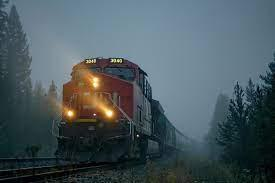What is the weather like in the image, and how does it affect the overall mood? The weather in the image is foggy, creating a mysterious and somewhat ethereal atmosphere. The mist enshrouds the environment, adding a sense of quiet and solitude, which is accentuated by the singular presence of the train emerging from the fog. Could you tell me more about the type of train in the image? Certainly, the train in the image is a modern freight locomotive, likely used for transporting goods over long distances. Its design suggests high efficiency and power, capable of traversing diverse terrains and weather conditions like the fog present in the image. 